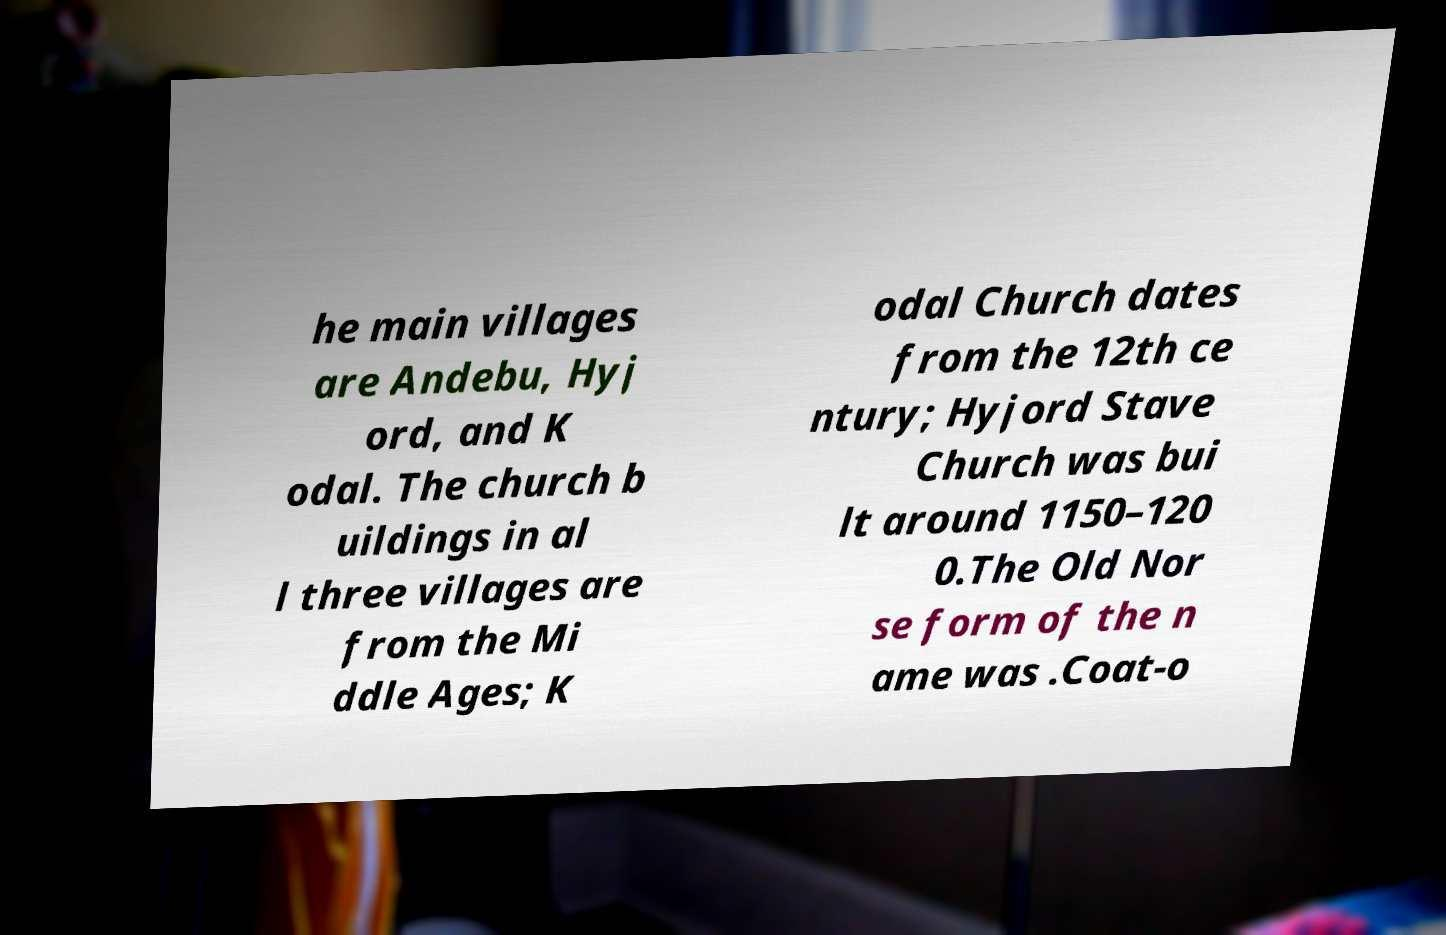I need the written content from this picture converted into text. Can you do that? he main villages are Andebu, Hyj ord, and K odal. The church b uildings in al l three villages are from the Mi ddle Ages; K odal Church dates from the 12th ce ntury; Hyjord Stave Church was bui lt around 1150–120 0.The Old Nor se form of the n ame was .Coat-o 